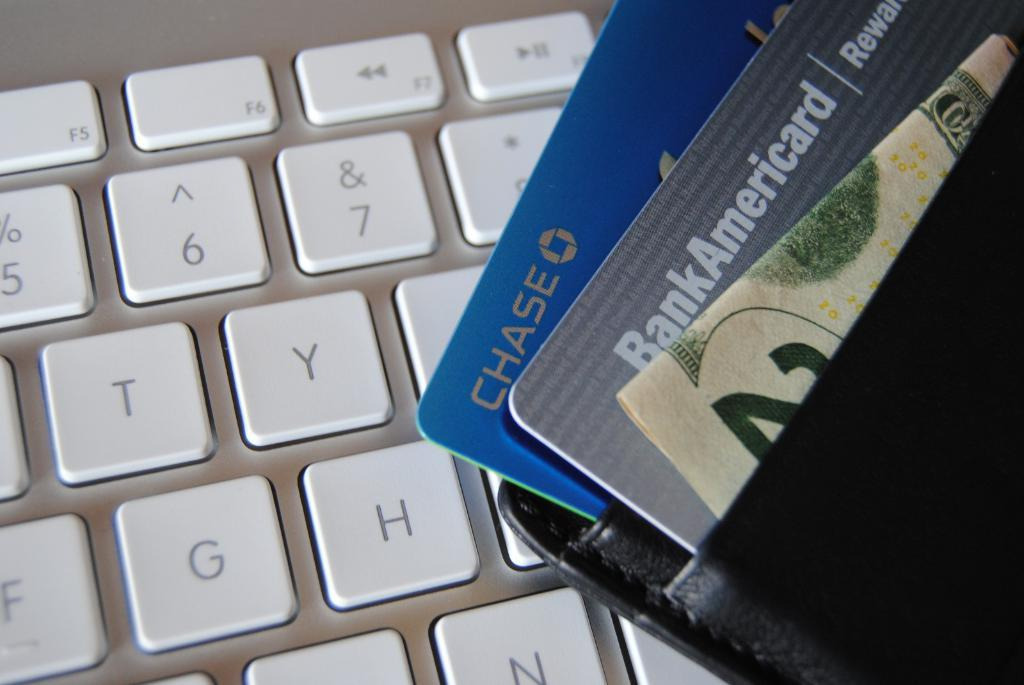Provide a one-sentence caption for the provided image. A blue chase credit card is in the wallet. 